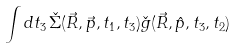Convert formula to latex. <formula><loc_0><loc_0><loc_500><loc_500>\int d t _ { 3 } \, \check { \Sigma } ( \vec { R } , \vec { p } , t _ { 1 } , t _ { 3 } ) \check { g } ( \vec { R } , \hat { p } , t _ { 3 } , t _ { 2 } )</formula> 